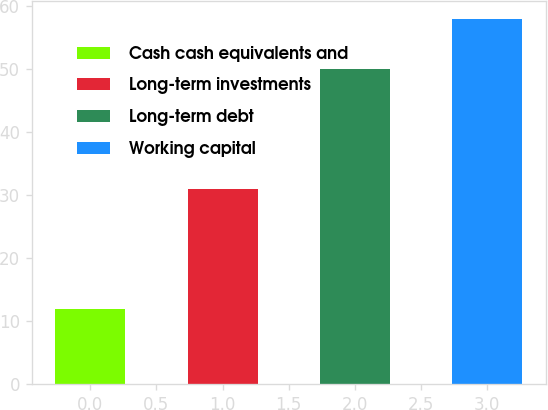Convert chart. <chart><loc_0><loc_0><loc_500><loc_500><bar_chart><fcel>Cash cash equivalents and<fcel>Long-term investments<fcel>Long-term debt<fcel>Working capital<nl><fcel>12<fcel>31<fcel>50<fcel>58<nl></chart> 